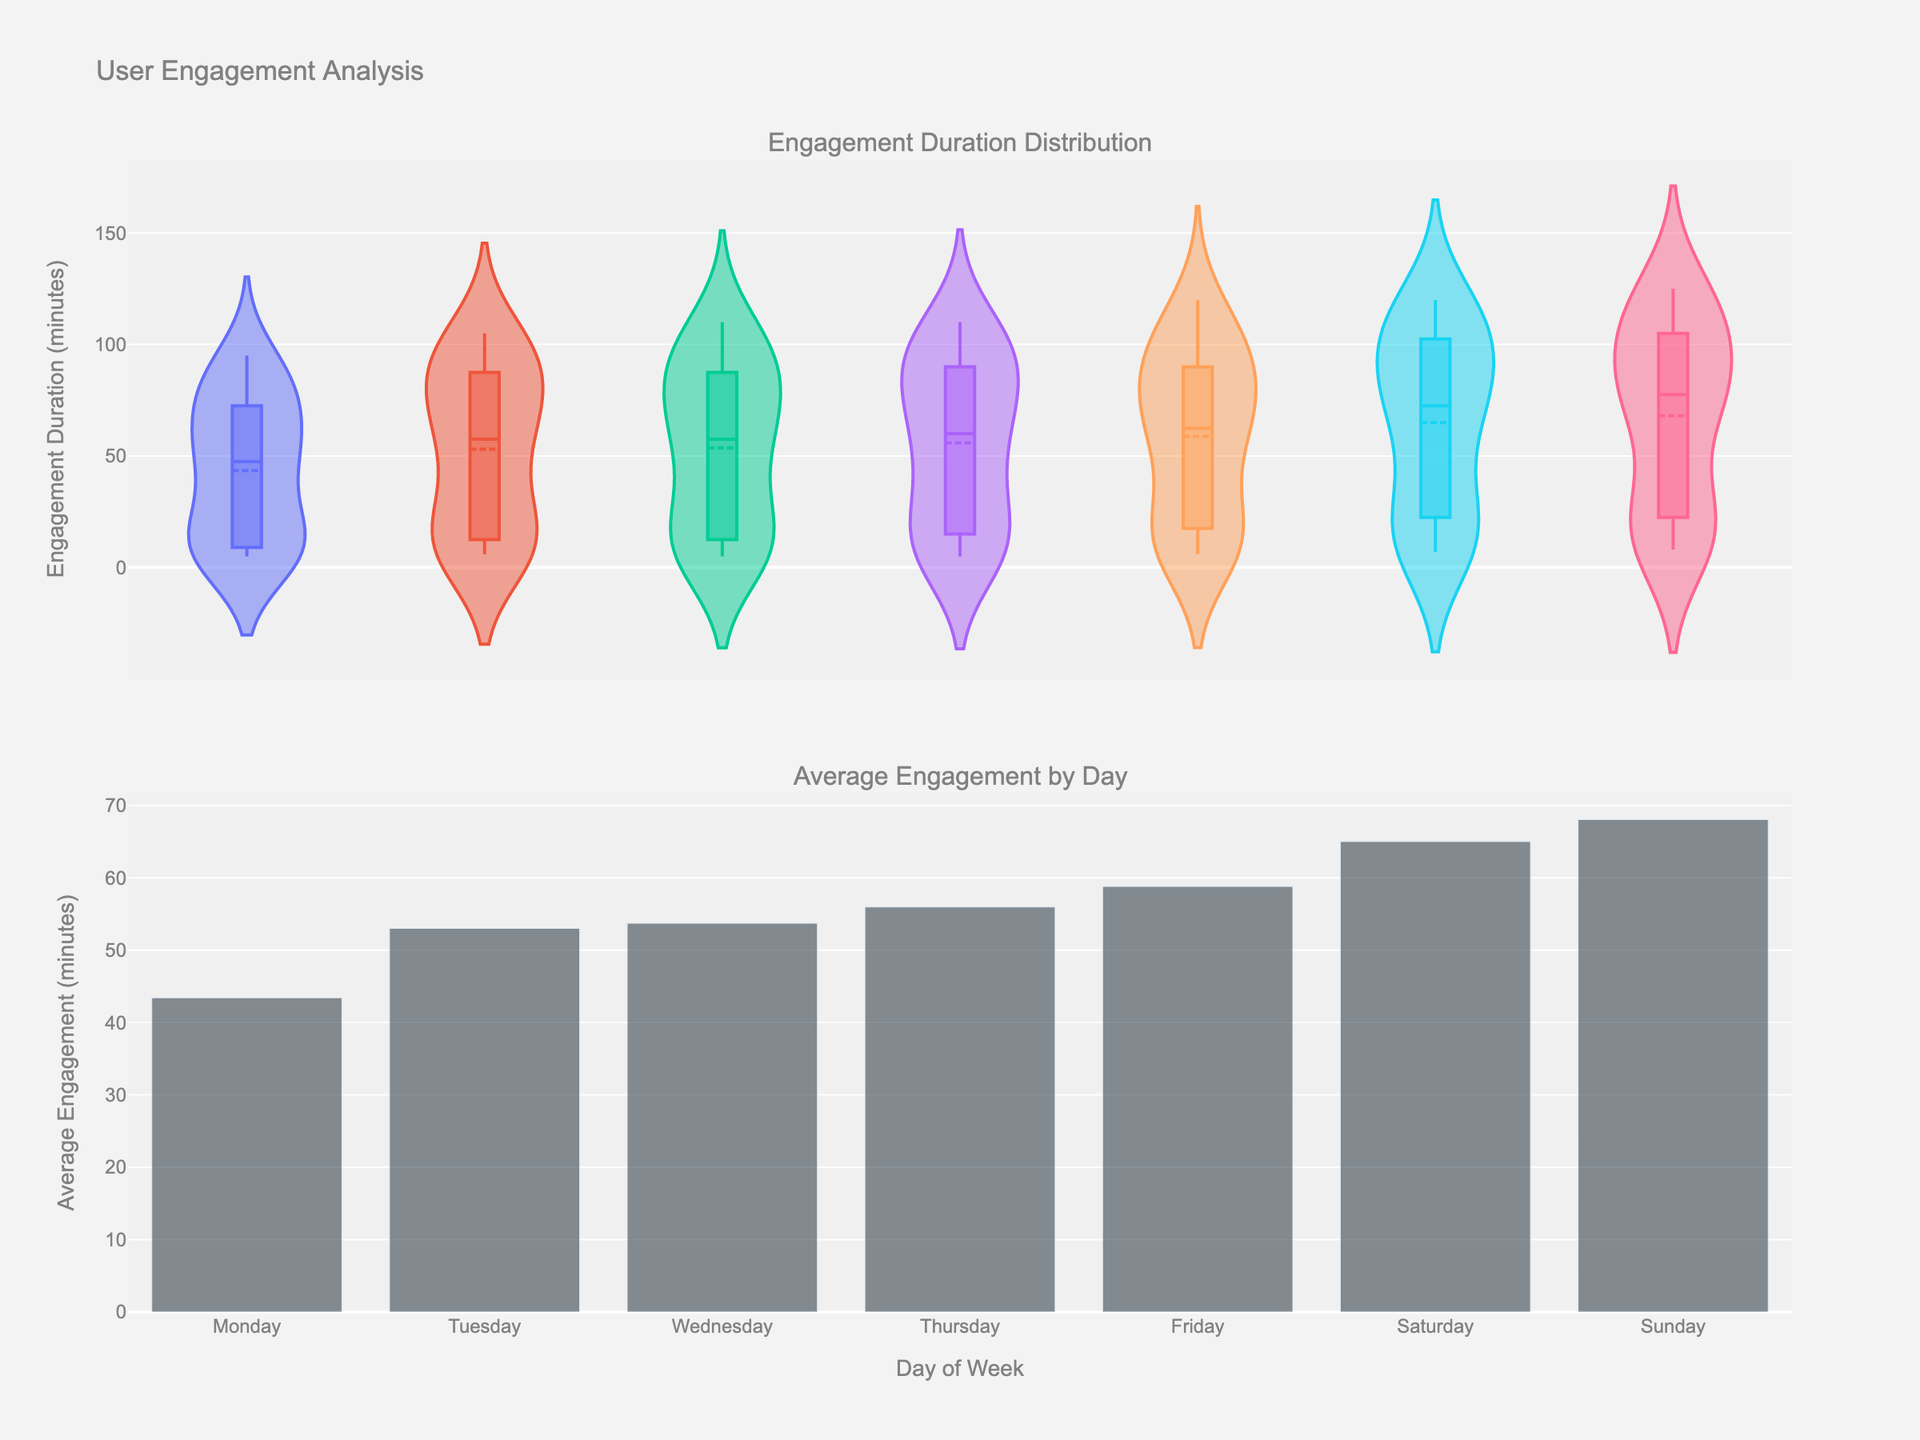What are the peak engagement hours on Monday when engagement duration is highest? From the violin plot in the first subplot, it can be observed that the engagement duration on Monday peaks from around 14:00 to 18:00 hours where the density is noticeably high.
Answer: 14:00 to 18:00 What is the average engagement duration for Wednesday? From the bar chart in the second subplot, the average engagement duration for each day is displayed. For Wednesday, the bar shows an approximate average duration of 65 minutes.
Answer: 65 minutes Which day shows the highest average engagement duration? By looking at the bar heights in the second subplot, Sunday stands out with the tallest bar, indicating the highest average engagement duration.
Answer: Sunday On which day is the engagement distribution most spread out, indicating high variability? The violin plots in the first subplot reveal the spread of engagement durations. Sunday has a wide spread, indicating high variability in engagement duration compared to other days.
Answer: Sunday How does the average engagement on Thursday compare to Tuesday? The bar chart in the second subplot shows average engagement durations. Comparing the bars for Thursday and Tuesday reveals that the average engagement is slightly higher on Thursday than Tuesday.
Answer: Thursday is higher For which day is the 25th percentile of engagement duration the lowest? In the violin plots, the box inside the violins represents the interquartile range. Monday's 25th percentile appears to be the lowest among all days, falling below the boxes of other days.
Answer: Monday What is the approximate range of engagement durations on Friday? From the violin plot for Friday, the engagement duration ranges from 5 minutes (minimum) to 120 minutes (maximum).
Answer: 5 to 120 minutes Are there any significant engagement peaks during non-working hours? Inspecting the first subplot, we see peaks in engagement durations post-16:00 hours on several days, indicating significant engagement during these non-working hours.
Answer: Yes, post-16:00 hours On which day does the engagement duration start to increase most significantly and at what hour? From the violin plots, Sunday shows significant increase in engagement duration starting around 10:00 hours.
Answer: Sunday at 10:00 hours What is the engagement duration at 12:00 on a typical Saturday? Referring to the first subplot's violin plot for Saturday, around 12:00 hours, the engagement duration peaks around 85 minutes.
Answer: 85 minutes 